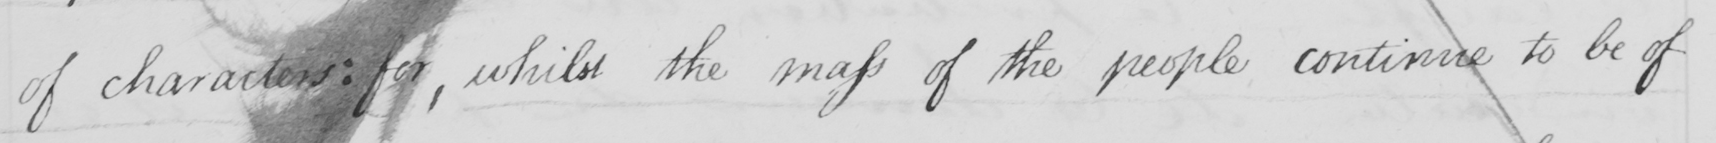What is written in this line of handwriting? of characters: for, whilst the mass of the people continue to be of 